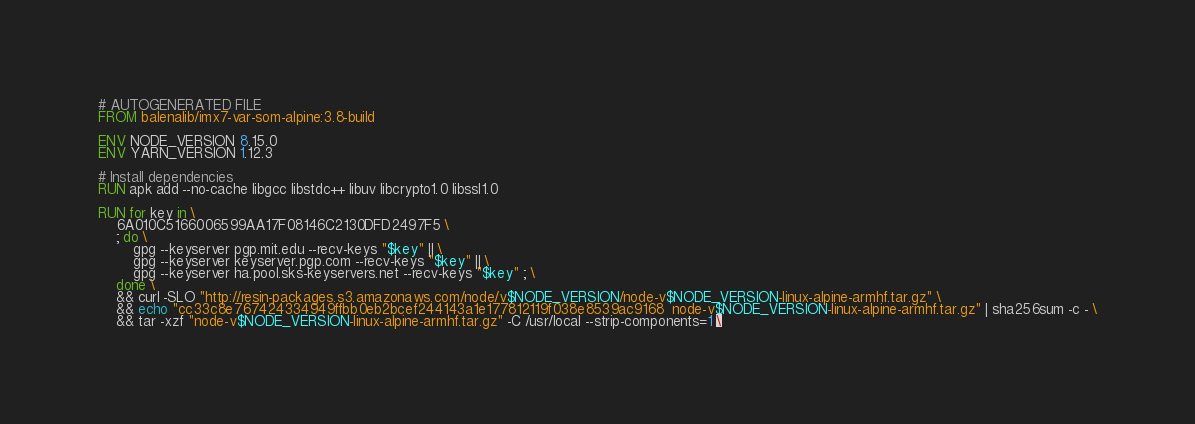<code> <loc_0><loc_0><loc_500><loc_500><_Dockerfile_># AUTOGENERATED FILE
FROM balenalib/imx7-var-som-alpine:3.8-build

ENV NODE_VERSION 8.15.0
ENV YARN_VERSION 1.12.3

# Install dependencies
RUN apk add --no-cache libgcc libstdc++ libuv libcrypto1.0 libssl1.0

RUN for key in \
	6A010C5166006599AA17F08146C2130DFD2497F5 \
	; do \
		gpg --keyserver pgp.mit.edu --recv-keys "$key" || \
		gpg --keyserver keyserver.pgp.com --recv-keys "$key" || \
		gpg --keyserver ha.pool.sks-keyservers.net --recv-keys "$key" ; \
	done \
	&& curl -SLO "http://resin-packages.s3.amazonaws.com/node/v$NODE_VERSION/node-v$NODE_VERSION-linux-alpine-armhf.tar.gz" \
	&& echo "cc33c8e767424334949ffbb0eb2bcef244143a1e177812119f038e8539ac9168  node-v$NODE_VERSION-linux-alpine-armhf.tar.gz" | sha256sum -c - \
	&& tar -xzf "node-v$NODE_VERSION-linux-alpine-armhf.tar.gz" -C /usr/local --strip-components=1 \</code> 